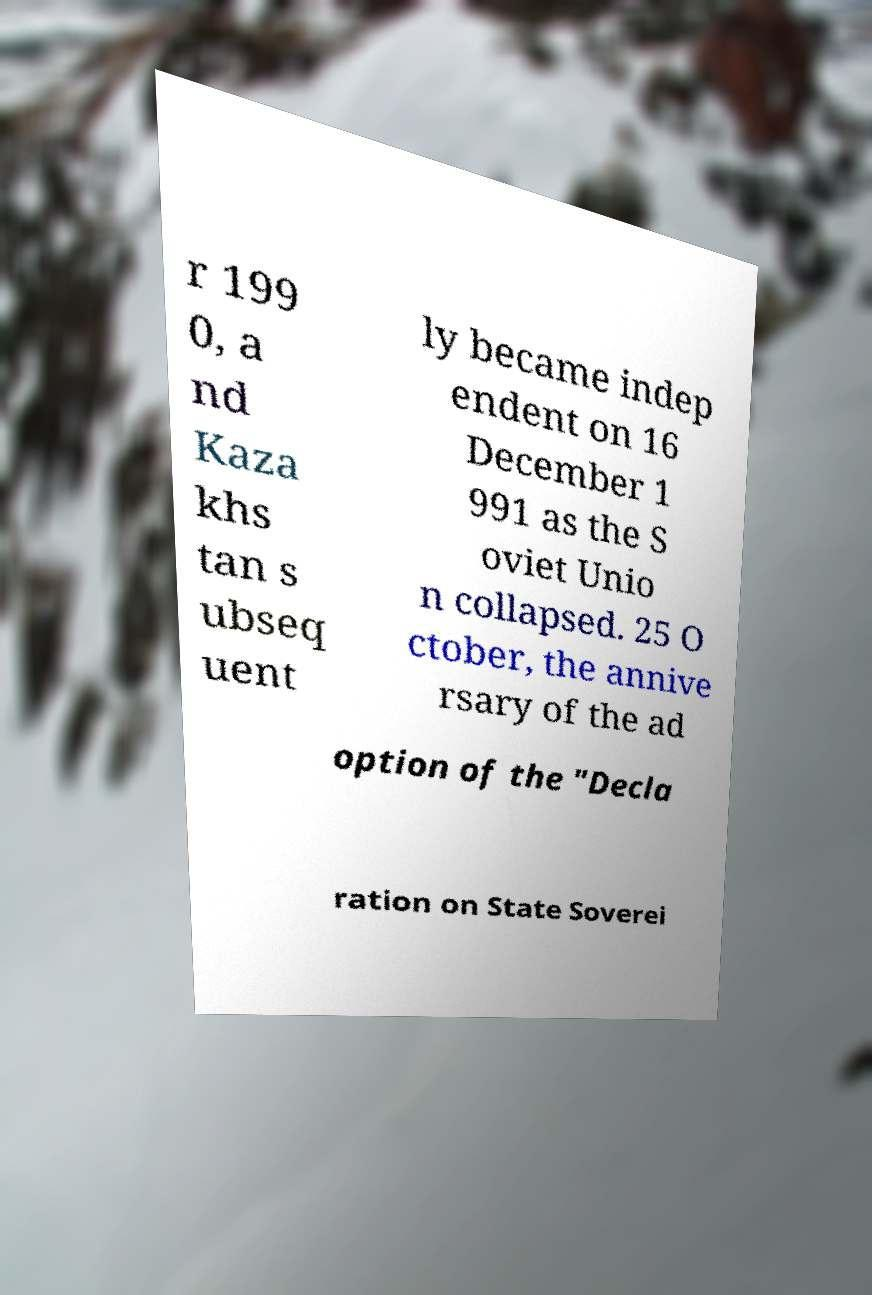For documentation purposes, I need the text within this image transcribed. Could you provide that? r 199 0, a nd Kaza khs tan s ubseq uent ly became indep endent on 16 December 1 991 as the S oviet Unio n collapsed. 25 O ctober, the annive rsary of the ad option of the "Decla ration on State Soverei 